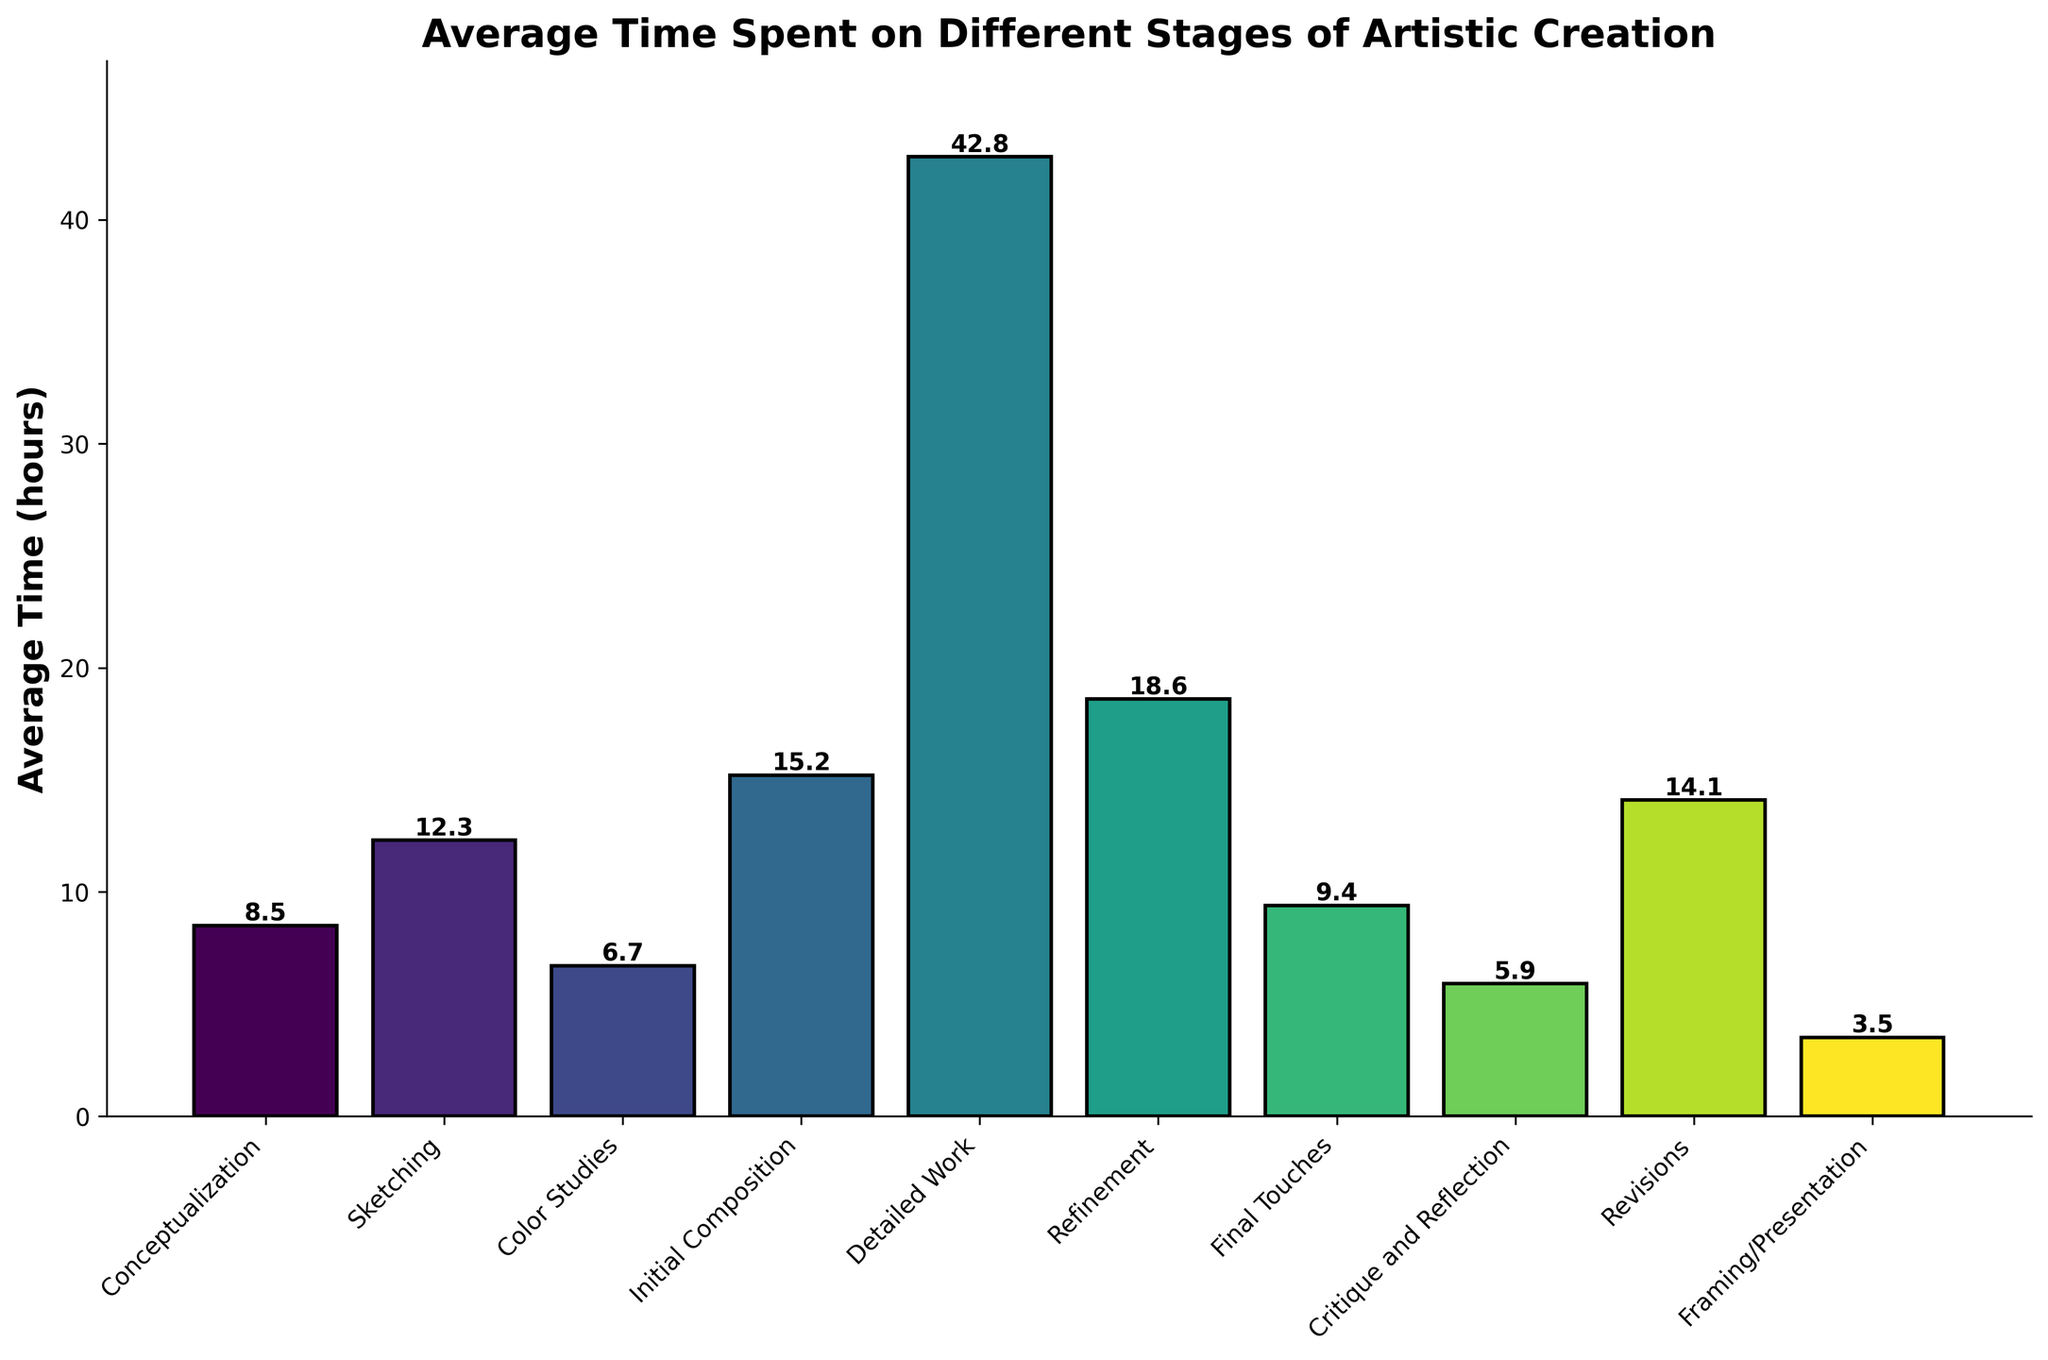What's the average time spent on Sketching and Initial Composition? To find the average time spent on Sketching and Initial Composition, sum their times (12.3 + 15.2) and then divide by 2. This calculation gives (12.3 + 15.2) = 27.5, and 27.5 / 2 = 13.75
Answer: 13.75 Which stage requires the most time? By looking at the heights of the bars, the Detailed Work stage is the highest, indicating that it requires the most time at 42.8 hours
Answer: Detailed Work Is the time spent on Refinement more than on Initial Composition and Revisions combined? Sum the time spent on Initial Composition and Revisions (15.2 + 14.1 = 29.3). Then, compare it to the time spent on Refinement (18.6 hours). Since 18.6 < 29.3, Refinement takes less time
Answer: No What is the time difference between the Conceptualization and Final Touches stages? Subtract the time spent on Final Touches from that on Conceptualization (8.5 - 9.4). The calculation gives -0.9 hours, meaning Final Touches takes 0.9 hours more than Conceptualization
Answer: 0.9 hours How much longer is Detailed Work compared to Color Studies? Subtract the time spent on Color Studies from that on Detailed Work (42.8 - 6.7). The calculation gives the difference as 36.1 hours
Answer: 36.1 hours What percentage of the total time is spent on Framing/Presentation? First, sum the times for all stages to get the total time. The total time is (8.5 + 12.3 + 6.7 + 15.2 + 42.8 + 18.6 + 9.4 + 5.9 + 14.1 + 3.5) = 136 hours. Then, calculate the percentage, (3.5 / 136) * 100 ≈ 2.57%
Answer: 2.57% Which stages have similar average times? By comparing the bar heights visually, we can see that the time spent on Sketching (12.3) and Revisions (14.1) are relatively close, with a difference of only 1.8 hours, which may be considered similar
Answer: Sketching and Revisions Which stage has the shortest average time, and how much is it? The bar for Framing/Presentation is the shortest, indicating it has the least average time at 3.5 hours
Answer: Framing/Presentation 